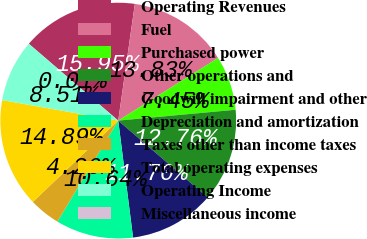Convert chart to OTSL. <chart><loc_0><loc_0><loc_500><loc_500><pie_chart><fcel>Operating Revenues<fcel>Fuel<fcel>Purchased power<fcel>Other operations and<fcel>Goodwill impairment and other<fcel>Depreciation and amortization<fcel>Taxes other than income taxes<fcel>Total operating expenses<fcel>Operating Income<fcel>Miscellaneous income<nl><fcel>15.95%<fcel>13.83%<fcel>7.45%<fcel>12.76%<fcel>11.7%<fcel>10.64%<fcel>4.26%<fcel>14.89%<fcel>8.51%<fcel>0.01%<nl></chart> 